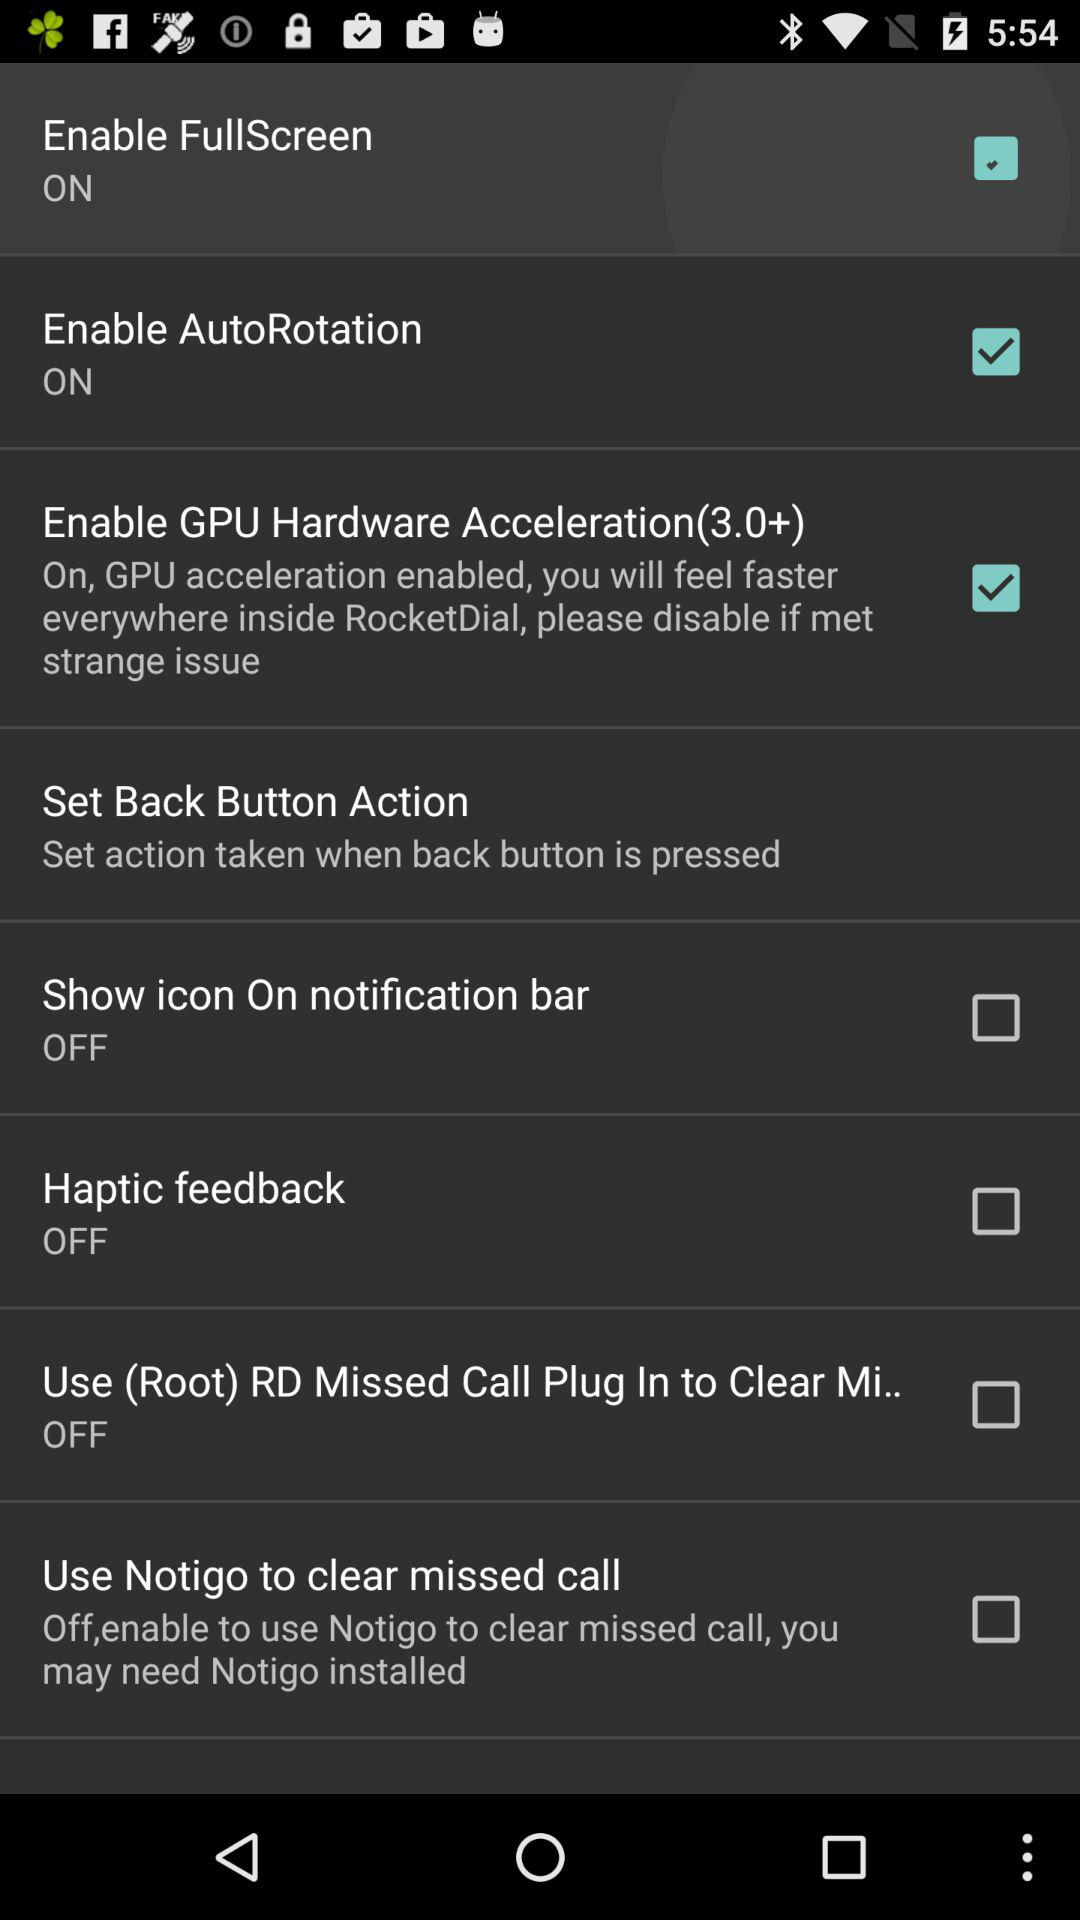What is the status of "Enable AutoRotation"? The status is on. 